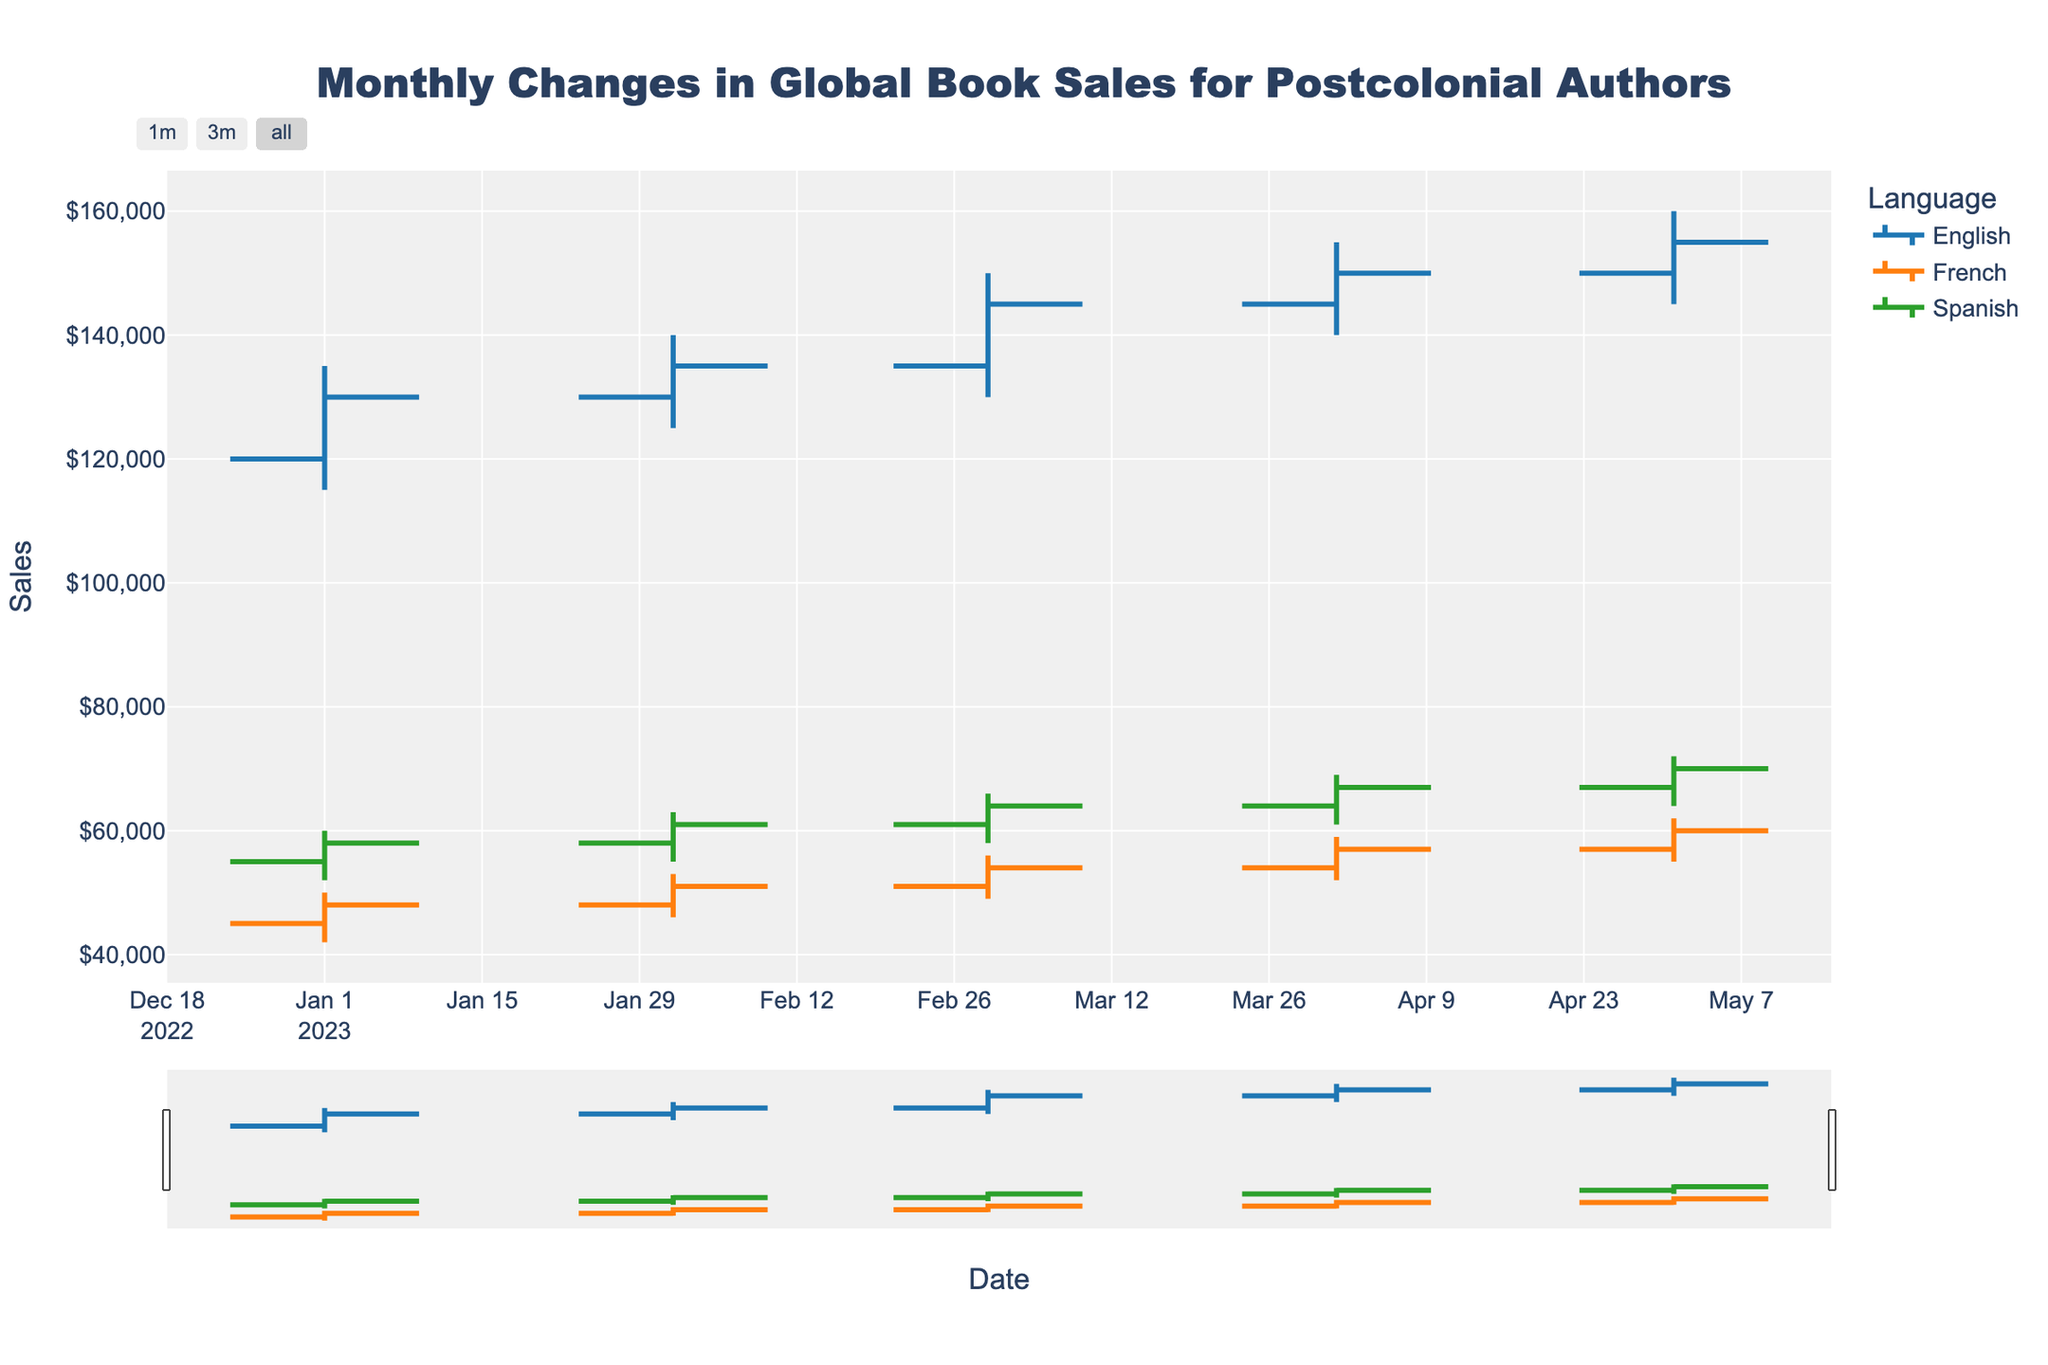What's the title of the plot? The title is located at the top of the plot. It provides an overview of what the plot is displaying.
Answer: Monthly Changes in Global Book Sales for Postcolonial Authors What does the x-axis represent? The x-axis is usually at the bottom of the plot and represents the time intervals for the data.
Answer: Date What does the y-axis represent? The y-axis, which is vertical, represents the metric being measured in the dataset.
Answer: Sales Which language had the highest sales in May 2023? Look along the May 2023 data points for the 'High' value. Compare the high values for English, French, and Spanish.
Answer: English How did English book sales change from January 2023 to May 2023? Examine the 'Close' values for English from January 2023 and May 2023. Note the movement of the closing values over time.
Answer: Increased from 130,000 to 155,000 Which language had the most consistent sales pattern from January to May 2023? Analyze the OHLC bars for each language from January to May 2023. Identify the language with the smallest variation in 'Open' and 'Close' values.
Answer: French In which month did Spanish books have their highest 'Open' sales? Identify the 'Open' values for Spanish books over the months and compare to find the highest.
Answer: May 2023 What was the lowest 'Low' value for French books over the period? Examine the 'Low' values for French books from January to May 2023 and pick the smallest value.
Answer: 42,000 How did the 'High' value for English books change from January to March 2023? Observe the 'High' values for English in January, February, and March; then, analyze the difference.
Answer: Increased from 135,000 to 150,000 Between French and Spanish, which language had higher 'Close' values on average? Calculate the average 'Close' value for French and Spanish across all months; then, compare these averages.
Answer: Spanish Which month showed the largest increase in 'Close' value for French books compared to the previous month? Compare the 'Close' values for French books month-on-month and identify the largest jump.
Answer: February to March 